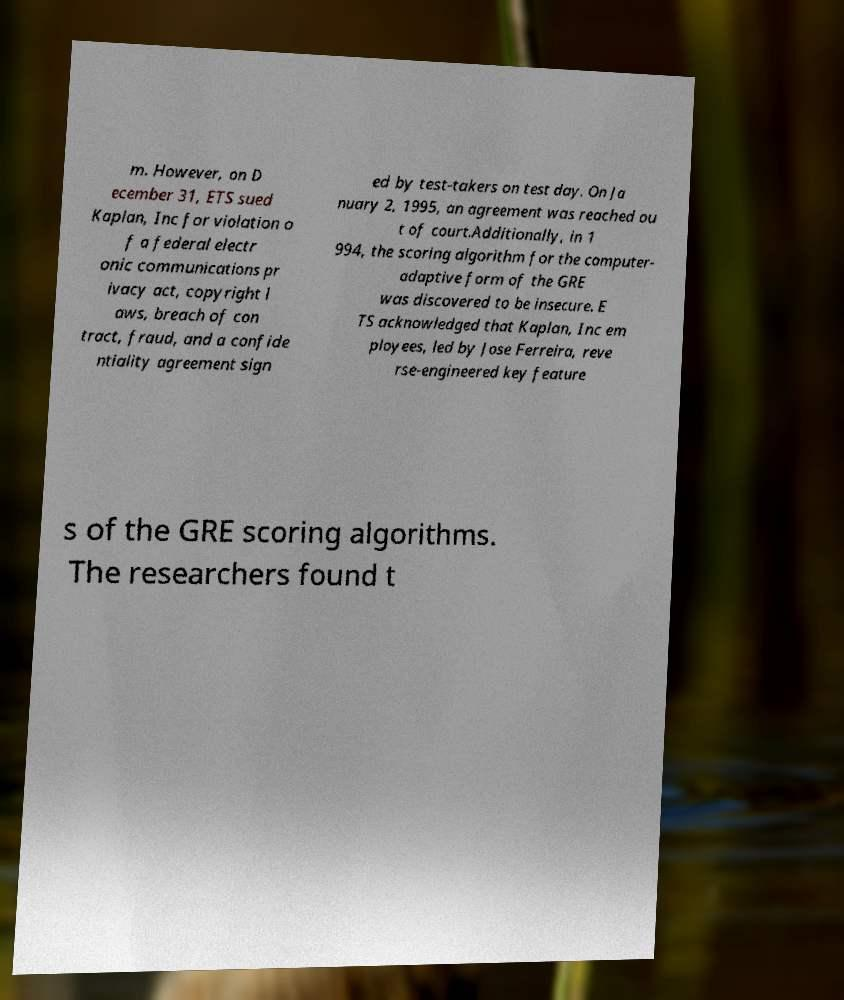There's text embedded in this image that I need extracted. Can you transcribe it verbatim? m. However, on D ecember 31, ETS sued Kaplan, Inc for violation o f a federal electr onic communications pr ivacy act, copyright l aws, breach of con tract, fraud, and a confide ntiality agreement sign ed by test-takers on test day. On Ja nuary 2, 1995, an agreement was reached ou t of court.Additionally, in 1 994, the scoring algorithm for the computer- adaptive form of the GRE was discovered to be insecure. E TS acknowledged that Kaplan, Inc em ployees, led by Jose Ferreira, reve rse-engineered key feature s of the GRE scoring algorithms. The researchers found t 